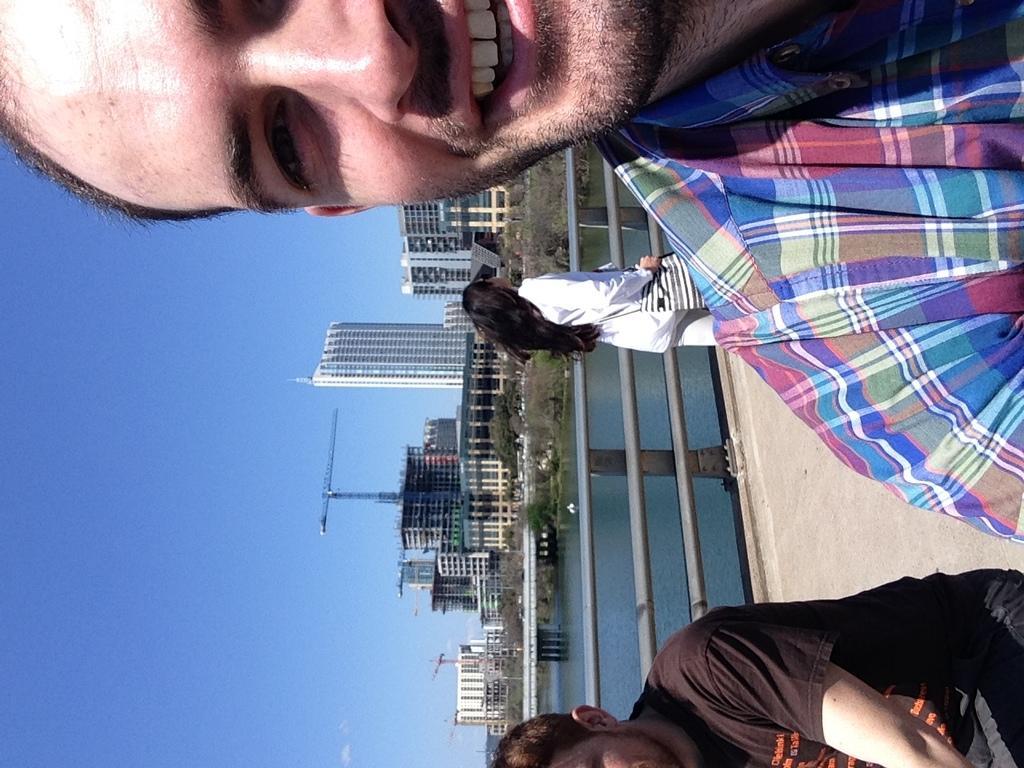In one or two sentences, can you explain what this image depicts? This image consists of three persons. On the right, there is a road. In the middle, we can see a railing and water. In the background, there are buildings. On the left, there is sky. 